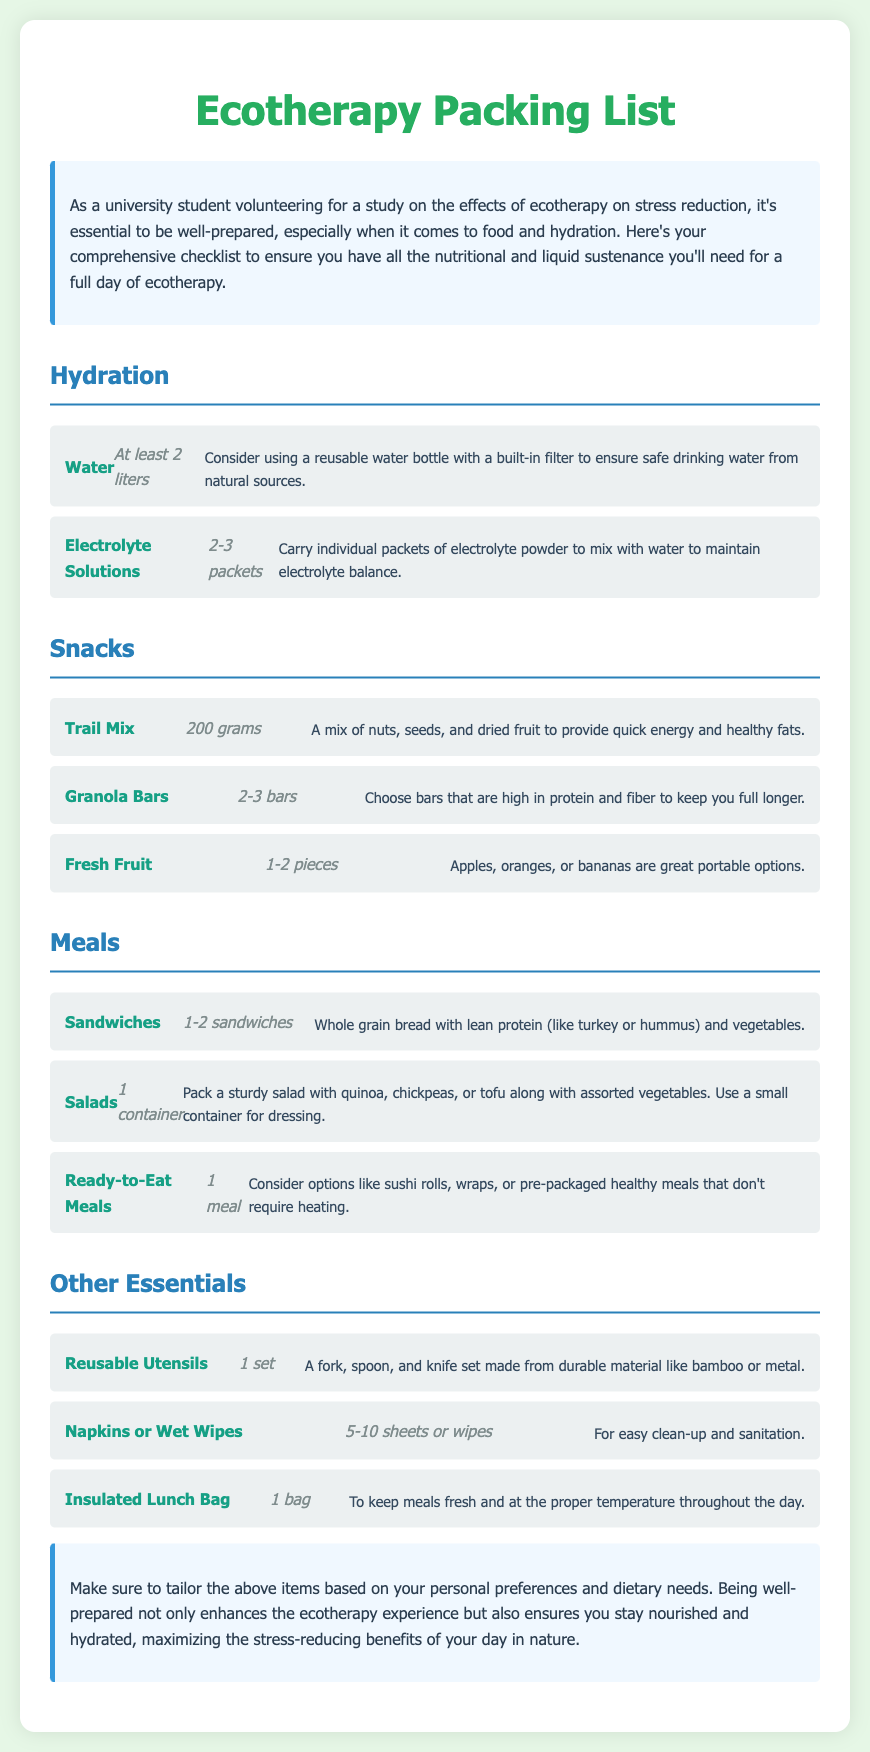What is the recommended amount of water to bring? The document suggests bringing at least 2 liters of water for hydration.
Answer: At least 2 liters How many granola bars should be packed? The checklist recommends packing 2-3 granola bars as a snack.
Answer: 2-3 bars What type of bag is recommended to keep meals fresh? The document advises using an insulated lunch bag for proper temperature control.
Answer: Insulated Lunch Bag What food item is suggested for quick energy? Trail mix is highlighted as a quick energy source in the snacks section.
Answer: Trail Mix How many packets of electrolyte solutions are recommended? The document suggests carrying 2-3 packets of electrolyte powder.
Answer: 2-3 packets What is one suggested main meal? The checklist lists sandwiches as one of the meal options for the day.
Answer: Sandwiches What type of fruit is recommended to bring? Fresh fruit options like apples, oranges, or bananas are suggested as portable snacks.
Answer: Apples, oranges, or bananas What is the purpose of carrying reusable utensils? Reusable utensils are included for ease of eating during the ecotherapy program.
Answer: For ease of eating What is the total quantity of snacks suggested? The document mentions three different snack items but does not provide a total quantity.
Answer: N/A 